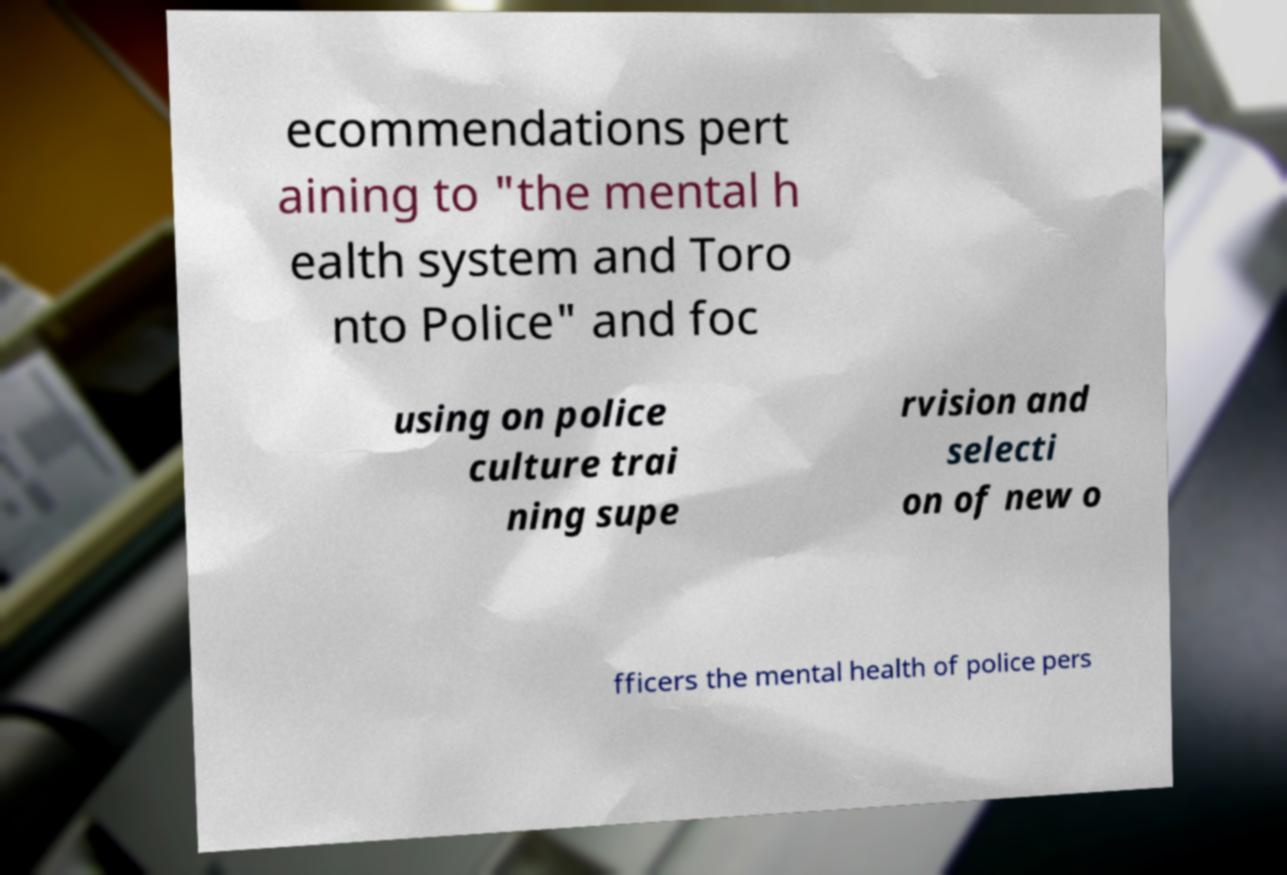Please read and relay the text visible in this image. What does it say? ecommendations pert aining to "the mental h ealth system and Toro nto Police" and foc using on police culture trai ning supe rvision and selecti on of new o fficers the mental health of police pers 